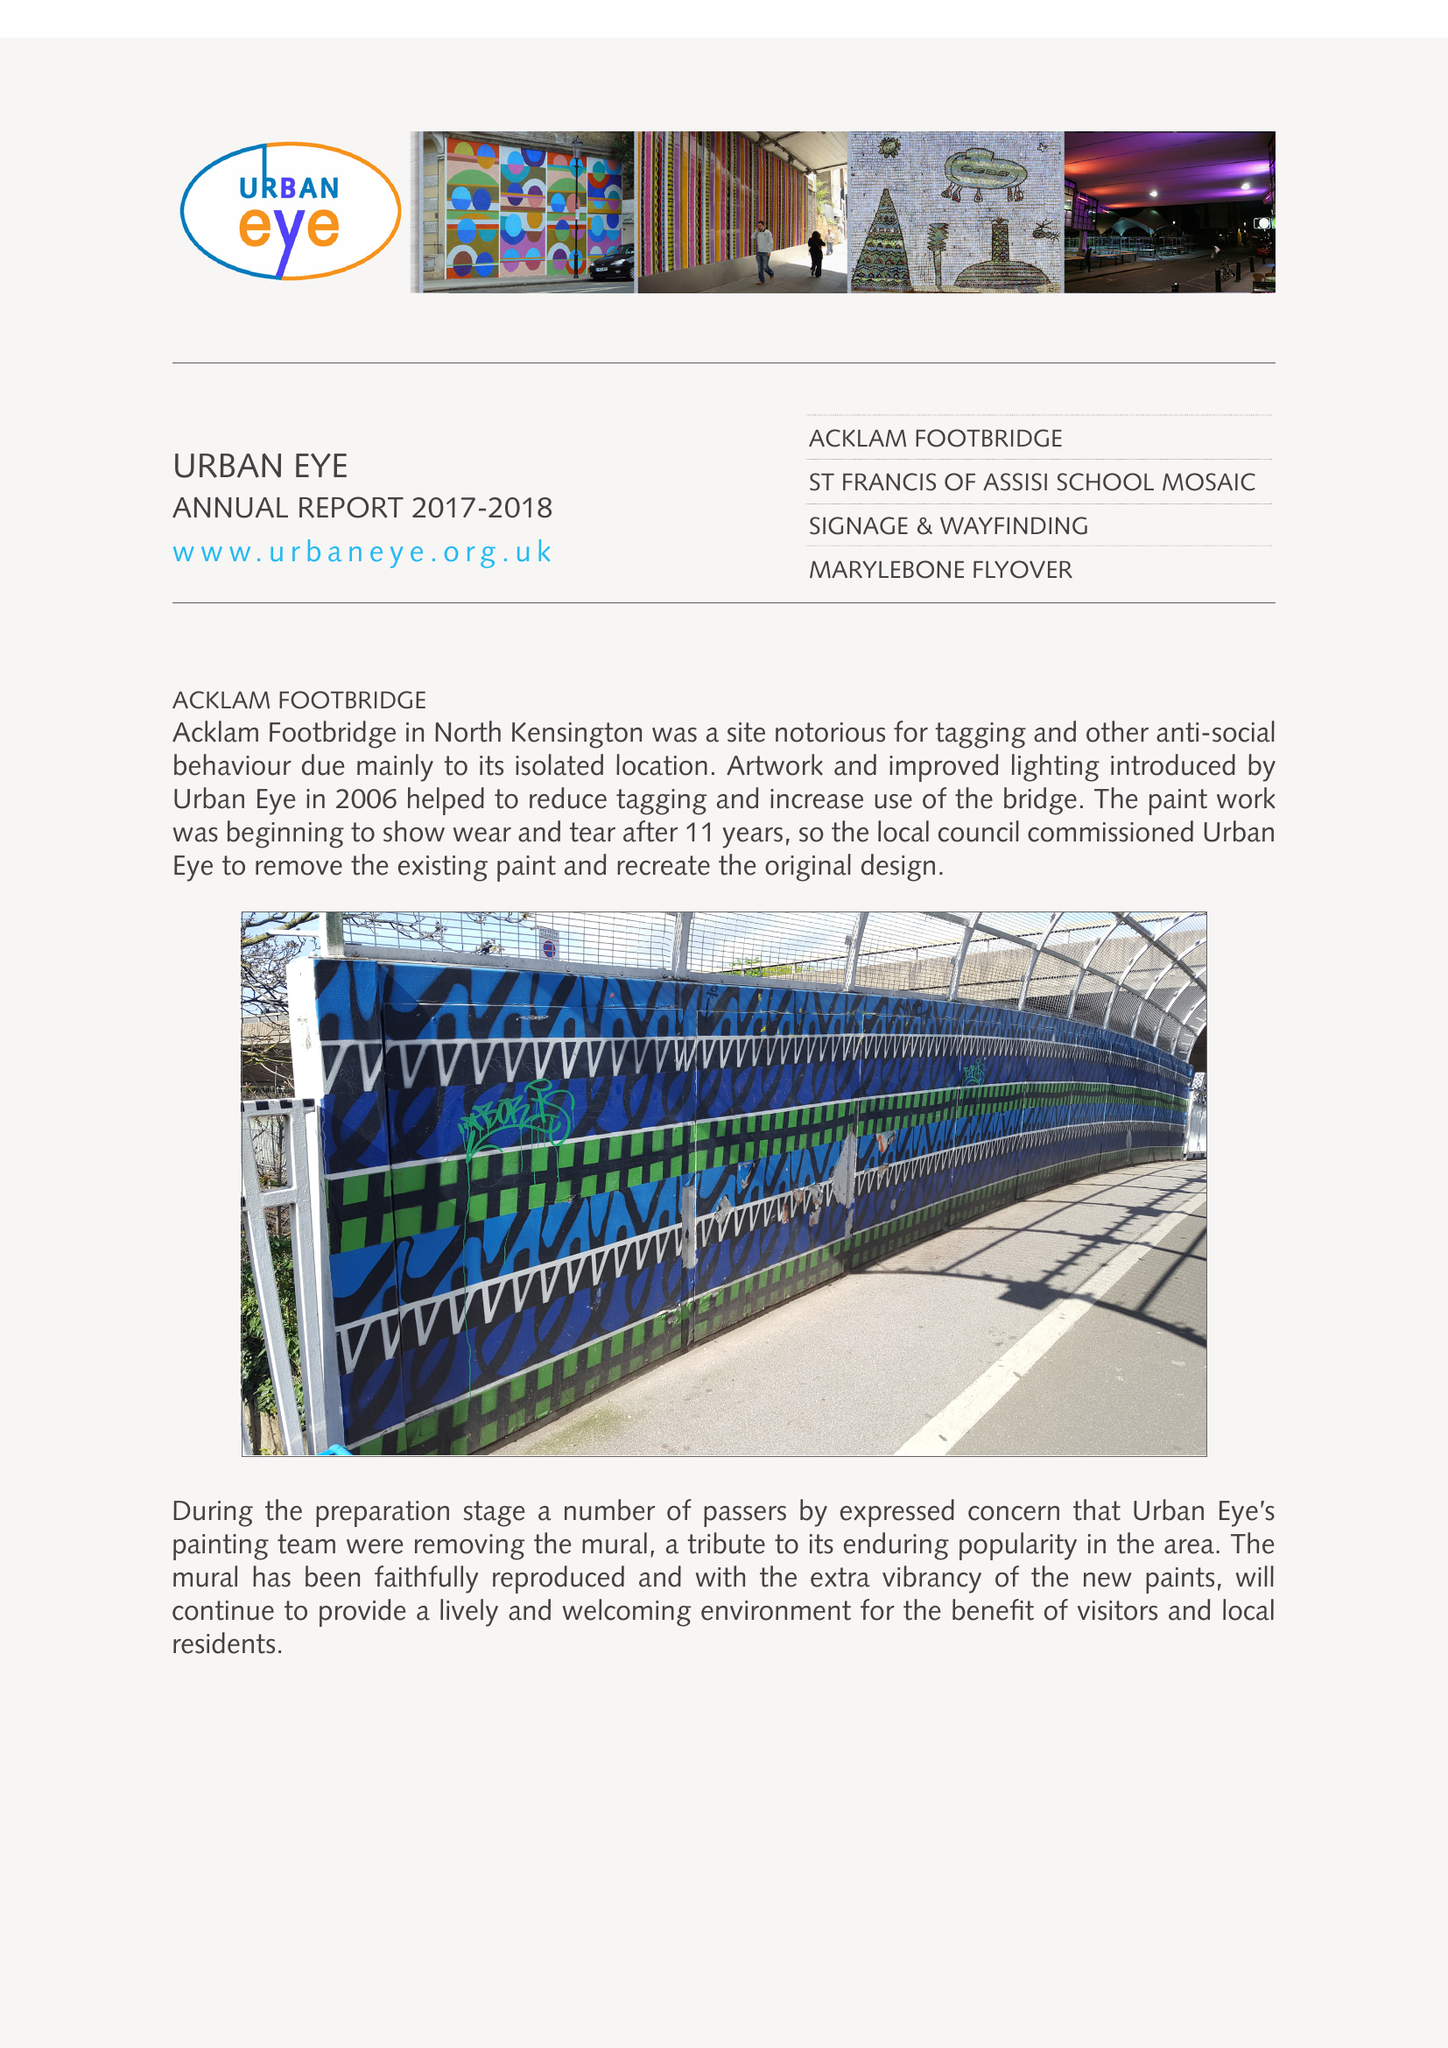What is the value for the address__postcode?
Answer the question using a single word or phrase. W11 4AT 